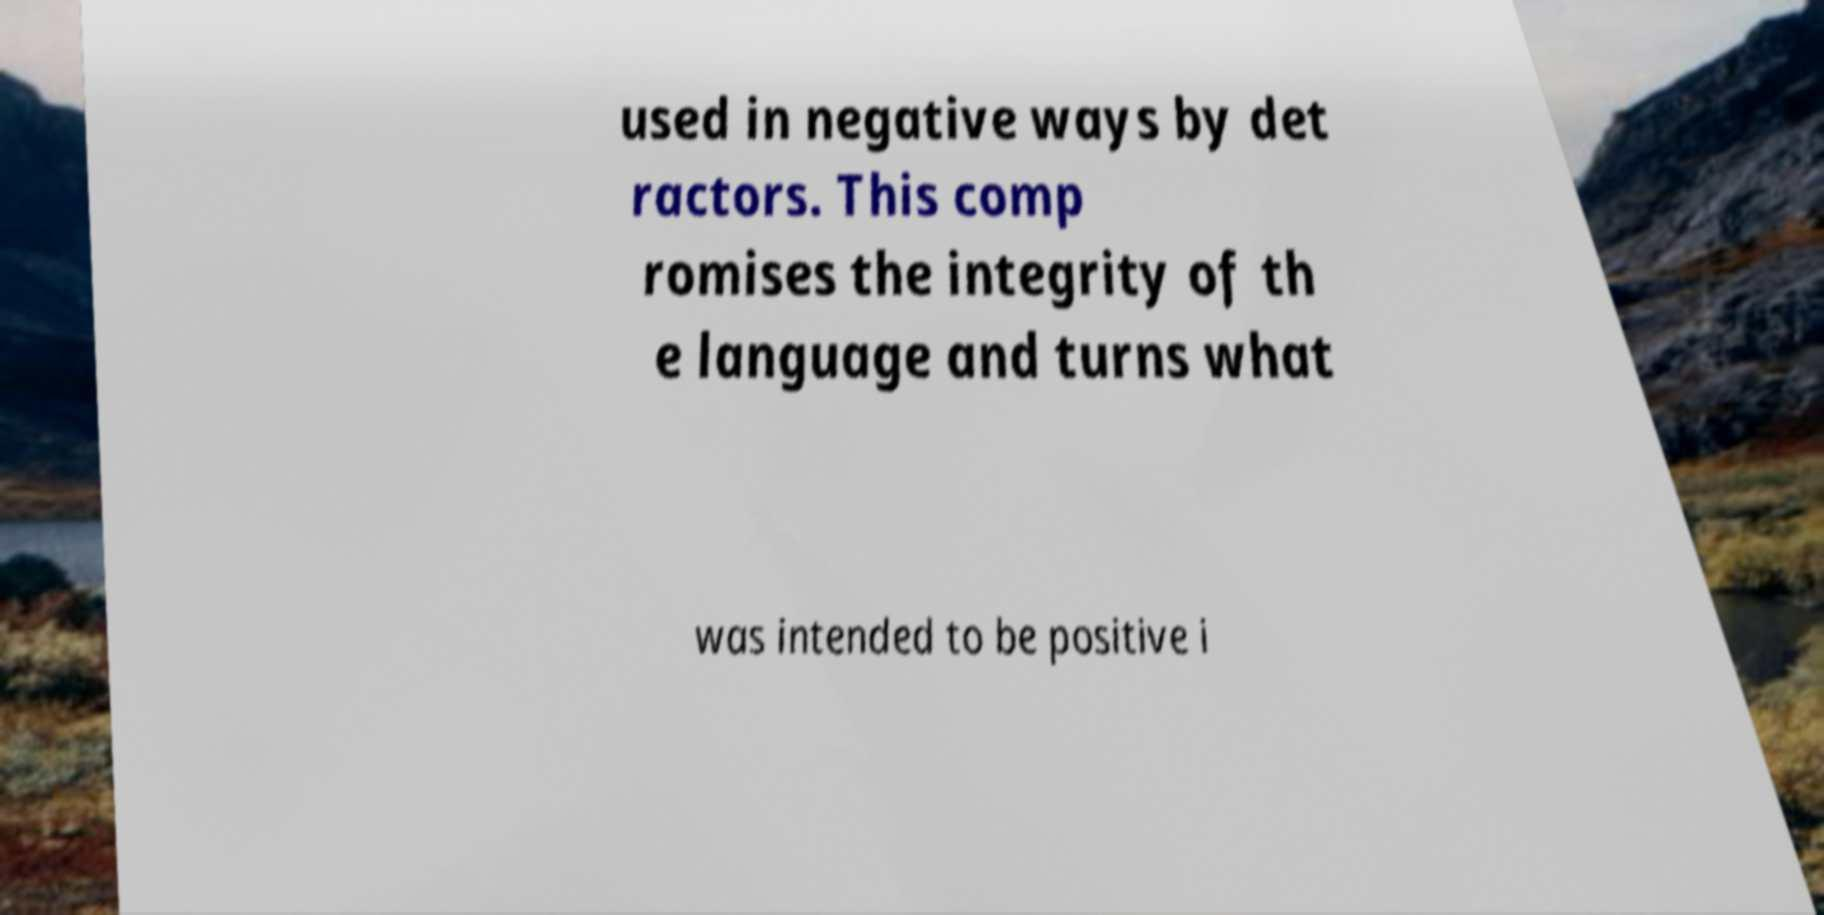Can you accurately transcribe the text from the provided image for me? used in negative ways by det ractors. This comp romises the integrity of th e language and turns what was intended to be positive i 